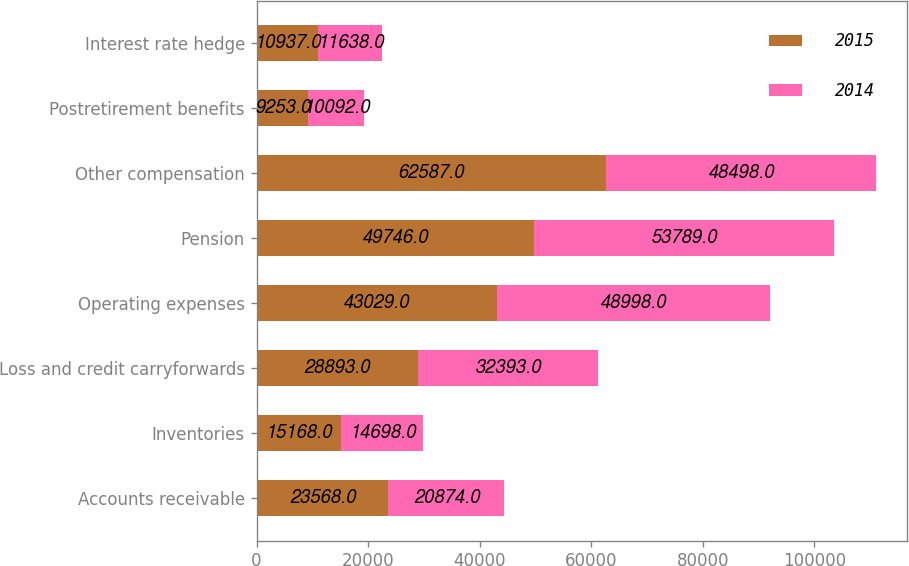Convert chart to OTSL. <chart><loc_0><loc_0><loc_500><loc_500><stacked_bar_chart><ecel><fcel>Accounts receivable<fcel>Inventories<fcel>Loss and credit carryforwards<fcel>Operating expenses<fcel>Pension<fcel>Other compensation<fcel>Postretirement benefits<fcel>Interest rate hedge<nl><fcel>2015<fcel>23568<fcel>15168<fcel>28893<fcel>43029<fcel>49746<fcel>62587<fcel>9253<fcel>10937<nl><fcel>2014<fcel>20874<fcel>14698<fcel>32393<fcel>48998<fcel>53789<fcel>48498<fcel>10092<fcel>11638<nl></chart> 